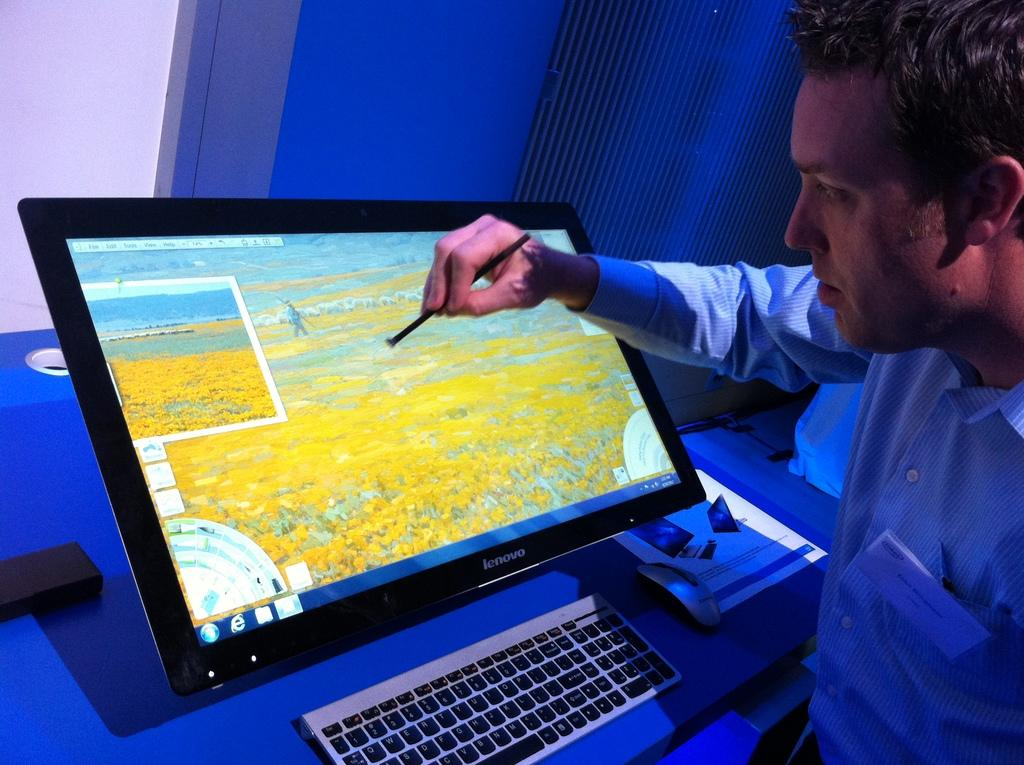<image>
Provide a brief description of the given image. a man using a stylus to manipulate the screen of a large lenovo tablet 